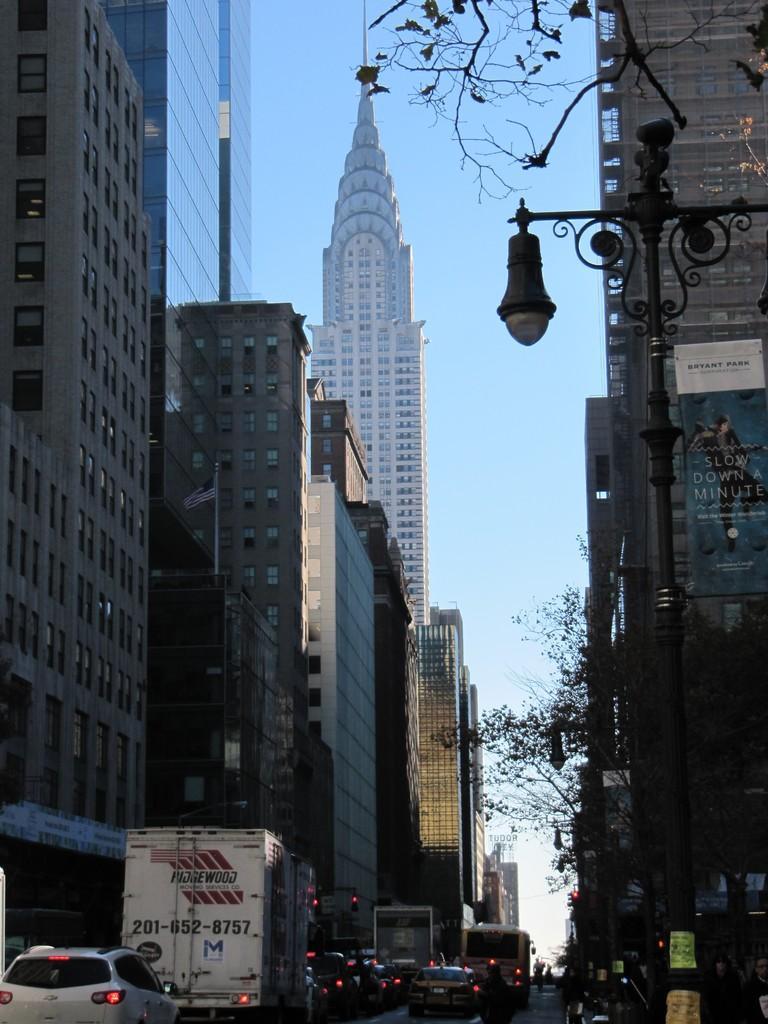How would you summarize this image in a sentence or two? On the left side, there are vehicles on the road. On both sides of this road, there are buildings. On the right side, there is a light attached to a pole. In the background, there are clouds in the blue sky. 